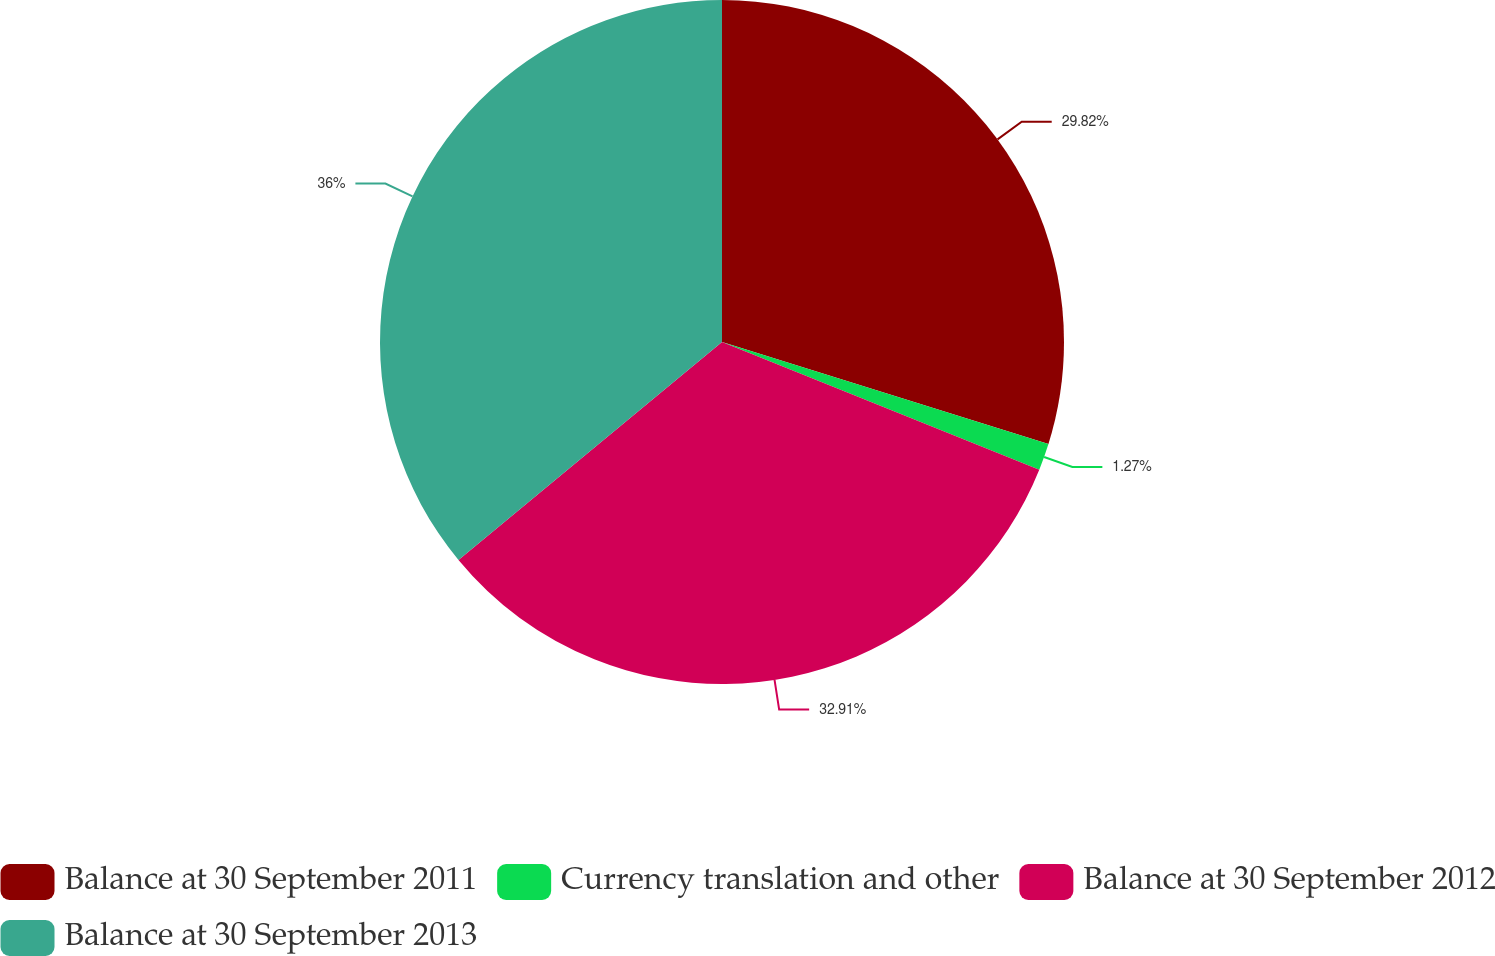Convert chart. <chart><loc_0><loc_0><loc_500><loc_500><pie_chart><fcel>Balance at 30 September 2011<fcel>Currency translation and other<fcel>Balance at 30 September 2012<fcel>Balance at 30 September 2013<nl><fcel>29.82%<fcel>1.27%<fcel>32.91%<fcel>36.0%<nl></chart> 